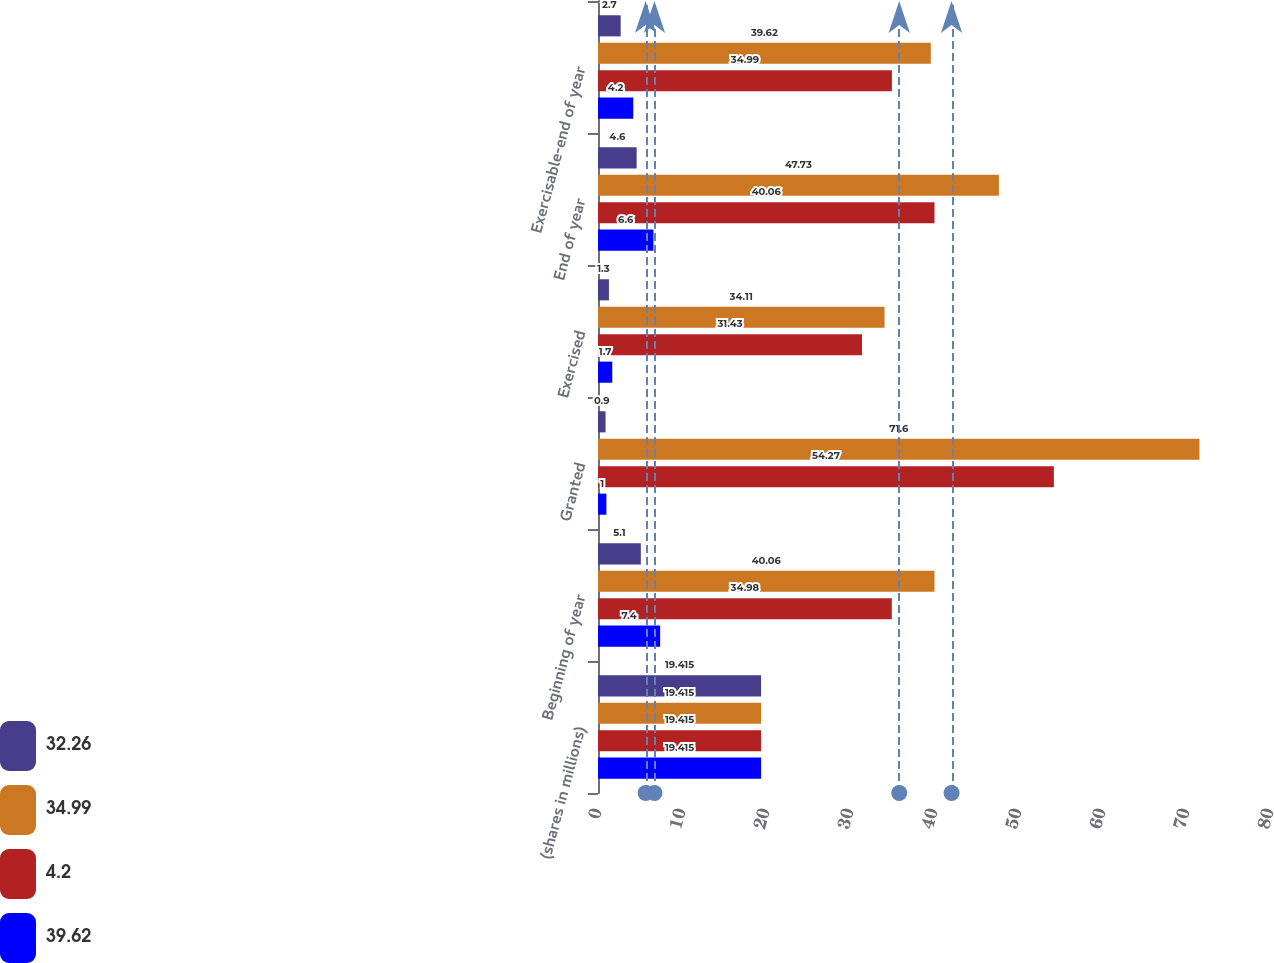<chart> <loc_0><loc_0><loc_500><loc_500><stacked_bar_chart><ecel><fcel>(shares in millions)<fcel>Beginning of year<fcel>Granted<fcel>Exercised<fcel>End of year<fcel>Exercisable-end of year<nl><fcel>32.26<fcel>19.415<fcel>5.1<fcel>0.9<fcel>1.3<fcel>4.6<fcel>2.7<nl><fcel>34.99<fcel>19.415<fcel>40.06<fcel>71.6<fcel>34.11<fcel>47.73<fcel>39.62<nl><fcel>4.2<fcel>19.415<fcel>34.98<fcel>54.27<fcel>31.43<fcel>40.06<fcel>34.99<nl><fcel>39.62<fcel>19.415<fcel>7.4<fcel>1<fcel>1.7<fcel>6.6<fcel>4.2<nl></chart> 